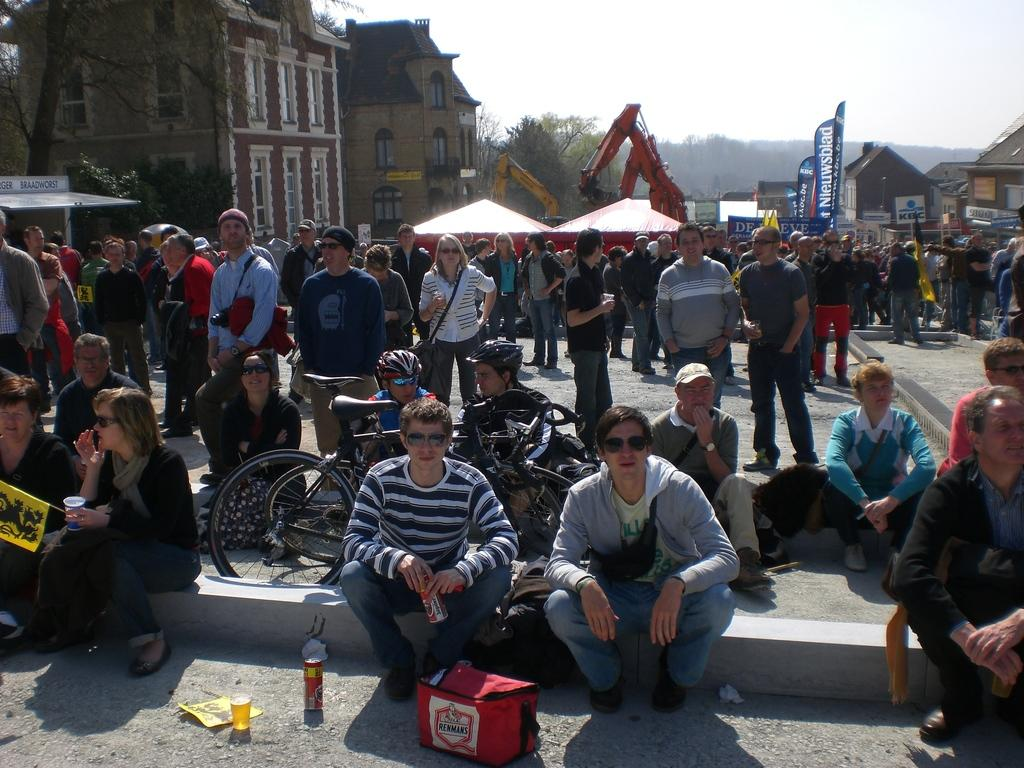What is the main subject in the middle of the image? There are many people in the middle of the image. What can be seen on the left side of the image? There are buildings on the left side of the image. What is visible at the top of the image? The sky is visible at the top of the image. What type of vegetation is present in the middle of the image? There are trees in the middle of the image. Can you provide advice on how to climb the hill in the image? There is no hill present in the image, so it is not possible to provide advice on climbing it. What type of vest is being worn by the person in the image? There are no people wearing vests in the image. 